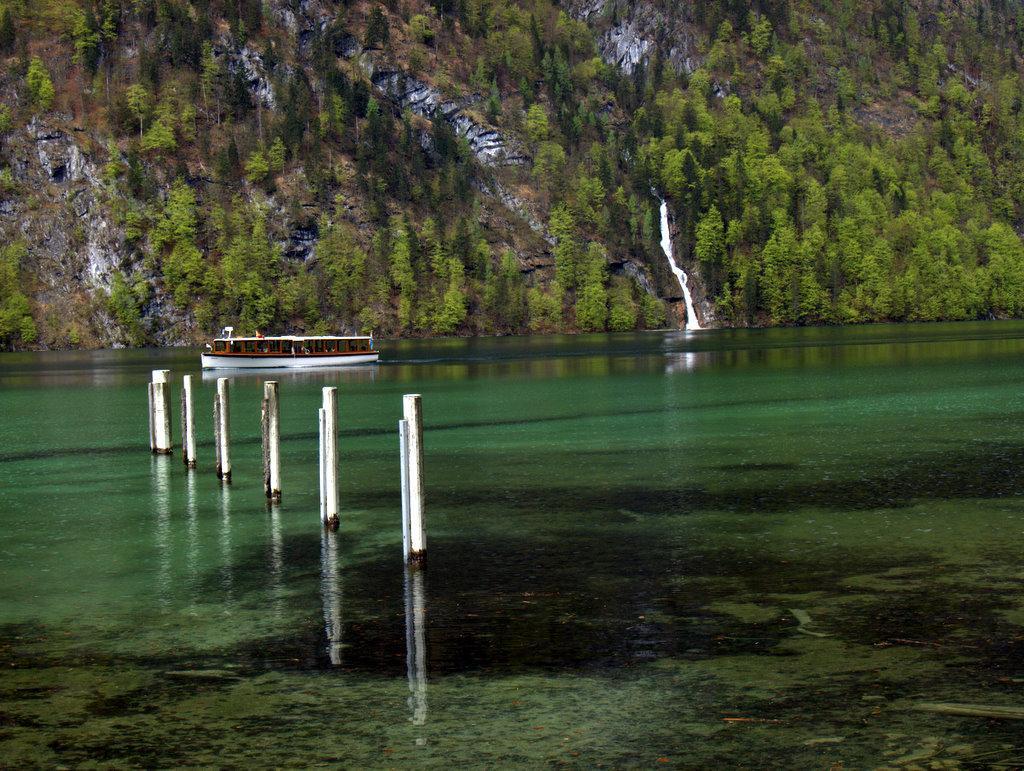Can you describe this image briefly? This is the water, here a boat is travelling in this water, these are the very big trees in this image. 